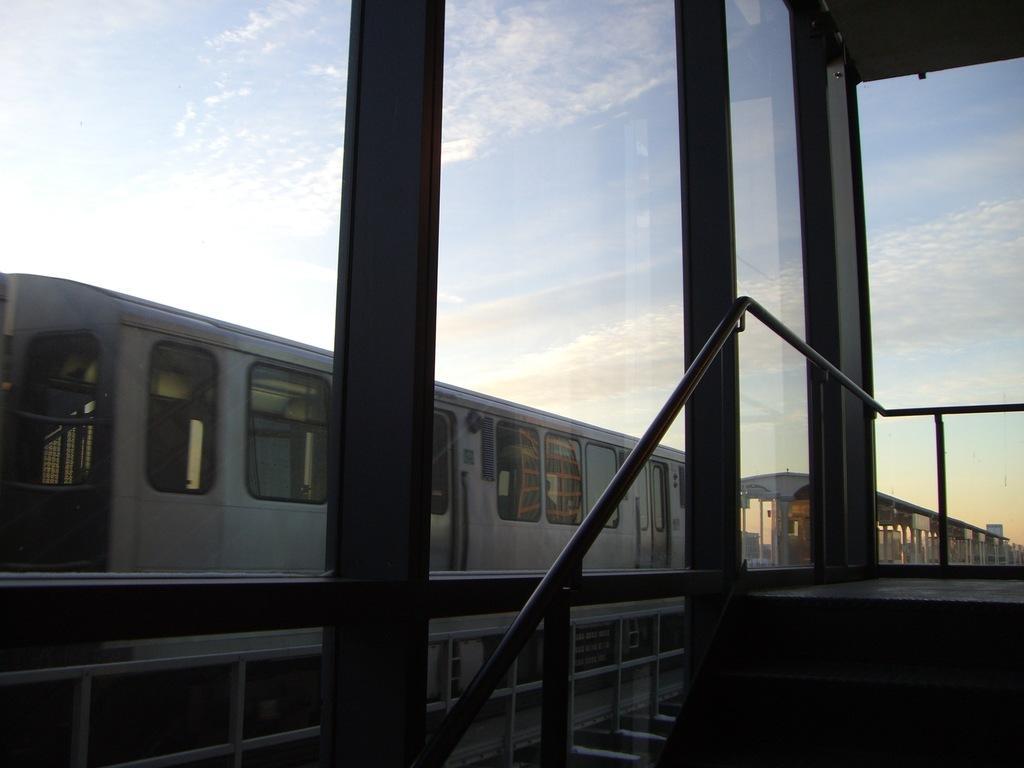Can you describe this image briefly? As we can see in the image there are trains and the sky. 